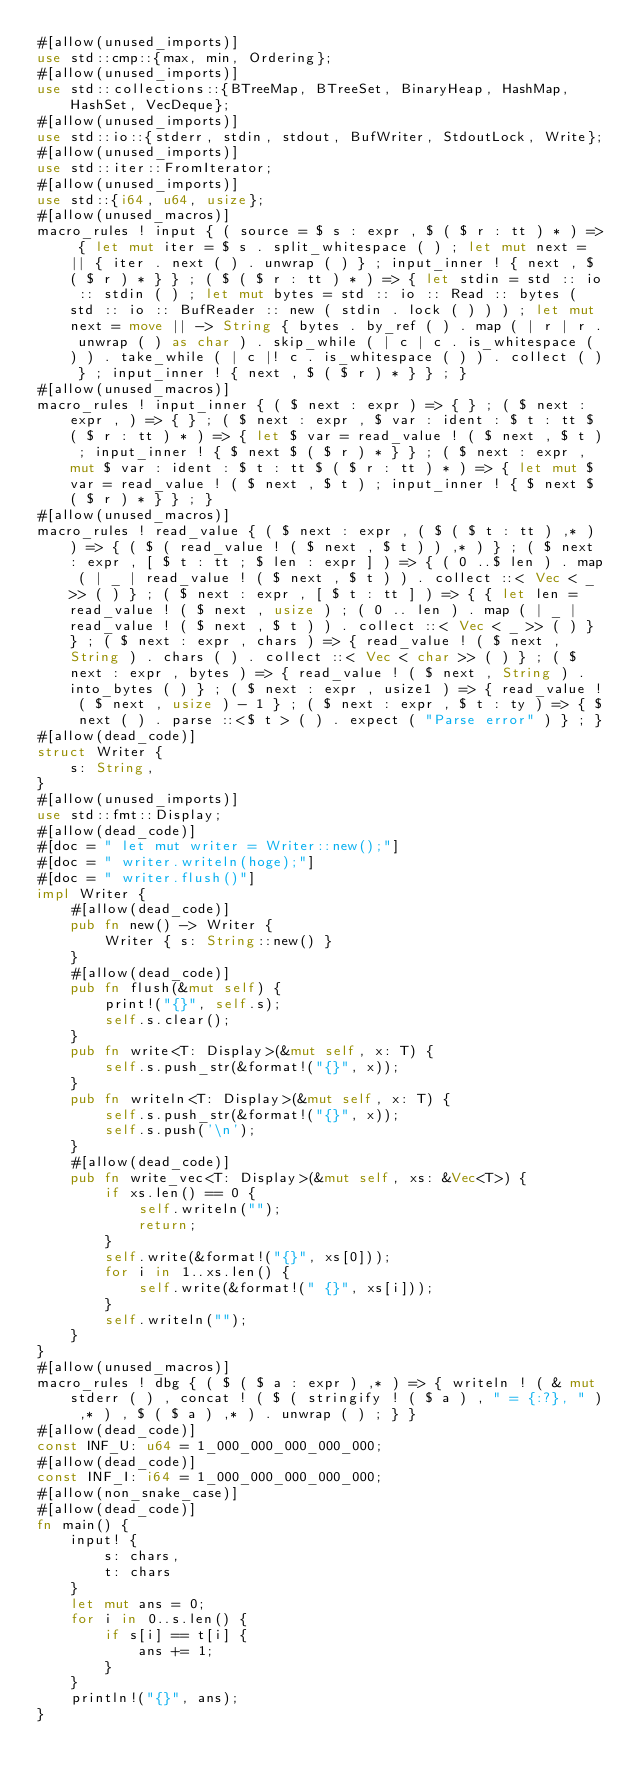Convert code to text. <code><loc_0><loc_0><loc_500><loc_500><_Rust_>#[allow(unused_imports)]
use std::cmp::{max, min, Ordering};
#[allow(unused_imports)]
use std::collections::{BTreeMap, BTreeSet, BinaryHeap, HashMap, HashSet, VecDeque};
#[allow(unused_imports)]
use std::io::{stderr, stdin, stdout, BufWriter, StdoutLock, Write};
#[allow(unused_imports)]
use std::iter::FromIterator;
#[allow(unused_imports)]
use std::{i64, u64, usize};
#[allow(unused_macros)]
macro_rules ! input { ( source = $ s : expr , $ ( $ r : tt ) * ) => { let mut iter = $ s . split_whitespace ( ) ; let mut next = || { iter . next ( ) . unwrap ( ) } ; input_inner ! { next , $ ( $ r ) * } } ; ( $ ( $ r : tt ) * ) => { let stdin = std :: io :: stdin ( ) ; let mut bytes = std :: io :: Read :: bytes ( std :: io :: BufReader :: new ( stdin . lock ( ) ) ) ; let mut next = move || -> String { bytes . by_ref ( ) . map ( | r | r . unwrap ( ) as char ) . skip_while ( | c | c . is_whitespace ( ) ) . take_while ( | c |! c . is_whitespace ( ) ) . collect ( ) } ; input_inner ! { next , $ ( $ r ) * } } ; }
#[allow(unused_macros)]
macro_rules ! input_inner { ( $ next : expr ) => { } ; ( $ next : expr , ) => { } ; ( $ next : expr , $ var : ident : $ t : tt $ ( $ r : tt ) * ) => { let $ var = read_value ! ( $ next , $ t ) ; input_inner ! { $ next $ ( $ r ) * } } ; ( $ next : expr , mut $ var : ident : $ t : tt $ ( $ r : tt ) * ) => { let mut $ var = read_value ! ( $ next , $ t ) ; input_inner ! { $ next $ ( $ r ) * } } ; }
#[allow(unused_macros)]
macro_rules ! read_value { ( $ next : expr , ( $ ( $ t : tt ) ,* ) ) => { ( $ ( read_value ! ( $ next , $ t ) ) ,* ) } ; ( $ next : expr , [ $ t : tt ; $ len : expr ] ) => { ( 0 ..$ len ) . map ( | _ | read_value ! ( $ next , $ t ) ) . collect ::< Vec < _ >> ( ) } ; ( $ next : expr , [ $ t : tt ] ) => { { let len = read_value ! ( $ next , usize ) ; ( 0 .. len ) . map ( | _ | read_value ! ( $ next , $ t ) ) . collect ::< Vec < _ >> ( ) } } ; ( $ next : expr , chars ) => { read_value ! ( $ next , String ) . chars ( ) . collect ::< Vec < char >> ( ) } ; ( $ next : expr , bytes ) => { read_value ! ( $ next , String ) . into_bytes ( ) } ; ( $ next : expr , usize1 ) => { read_value ! ( $ next , usize ) - 1 } ; ( $ next : expr , $ t : ty ) => { $ next ( ) . parse ::<$ t > ( ) . expect ( "Parse error" ) } ; }
#[allow(dead_code)]
struct Writer {
    s: String,
}
#[allow(unused_imports)]
use std::fmt::Display;
#[allow(dead_code)]
#[doc = " let mut writer = Writer::new();"]
#[doc = " writer.writeln(hoge);"]
#[doc = " writer.flush()"]
impl Writer {
    #[allow(dead_code)]
    pub fn new() -> Writer {
        Writer { s: String::new() }
    }
    #[allow(dead_code)]
    pub fn flush(&mut self) {
        print!("{}", self.s);
        self.s.clear();
    }
    pub fn write<T: Display>(&mut self, x: T) {
        self.s.push_str(&format!("{}", x));
    }
    pub fn writeln<T: Display>(&mut self, x: T) {
        self.s.push_str(&format!("{}", x));
        self.s.push('\n');
    }
    #[allow(dead_code)]
    pub fn write_vec<T: Display>(&mut self, xs: &Vec<T>) {
        if xs.len() == 0 {
            self.writeln("");
            return;
        }
        self.write(&format!("{}", xs[0]));
        for i in 1..xs.len() {
            self.write(&format!(" {}", xs[i]));
        }
        self.writeln("");
    }
}
#[allow(unused_macros)]
macro_rules ! dbg { ( $ ( $ a : expr ) ,* ) => { writeln ! ( & mut stderr ( ) , concat ! ( $ ( stringify ! ( $ a ) , " = {:?}, " ) ,* ) , $ ( $ a ) ,* ) . unwrap ( ) ; } }
#[allow(dead_code)]
const INF_U: u64 = 1_000_000_000_000_000;
#[allow(dead_code)]
const INF_I: i64 = 1_000_000_000_000_000;
#[allow(non_snake_case)]
#[allow(dead_code)]
fn main() {
    input! {
        s: chars,
        t: chars
    }
    let mut ans = 0;
    for i in 0..s.len() {
        if s[i] == t[i] {
            ans += 1;
        }
    }
    println!("{}", ans);
}</code> 